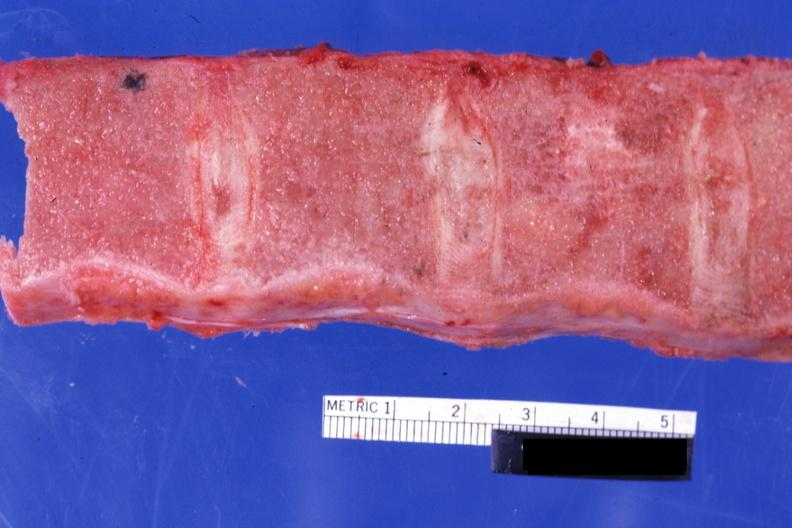what is present?
Answer the question using a single word or phrase. Bone marrow 